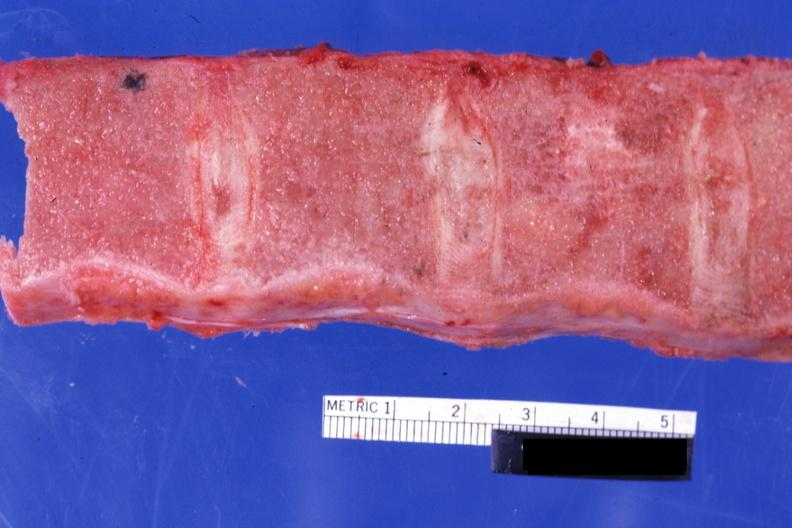what is present?
Answer the question using a single word or phrase. Bone marrow 